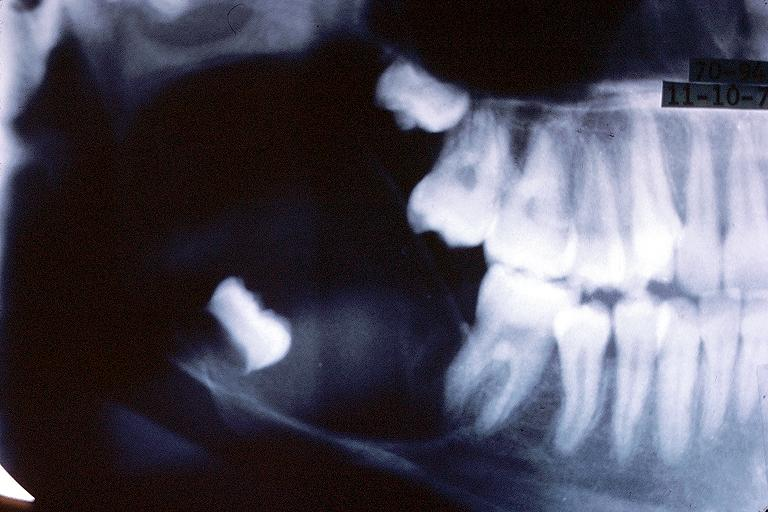does gangrene show unicystic ameloblastom?
Answer the question using a single word or phrase. No 